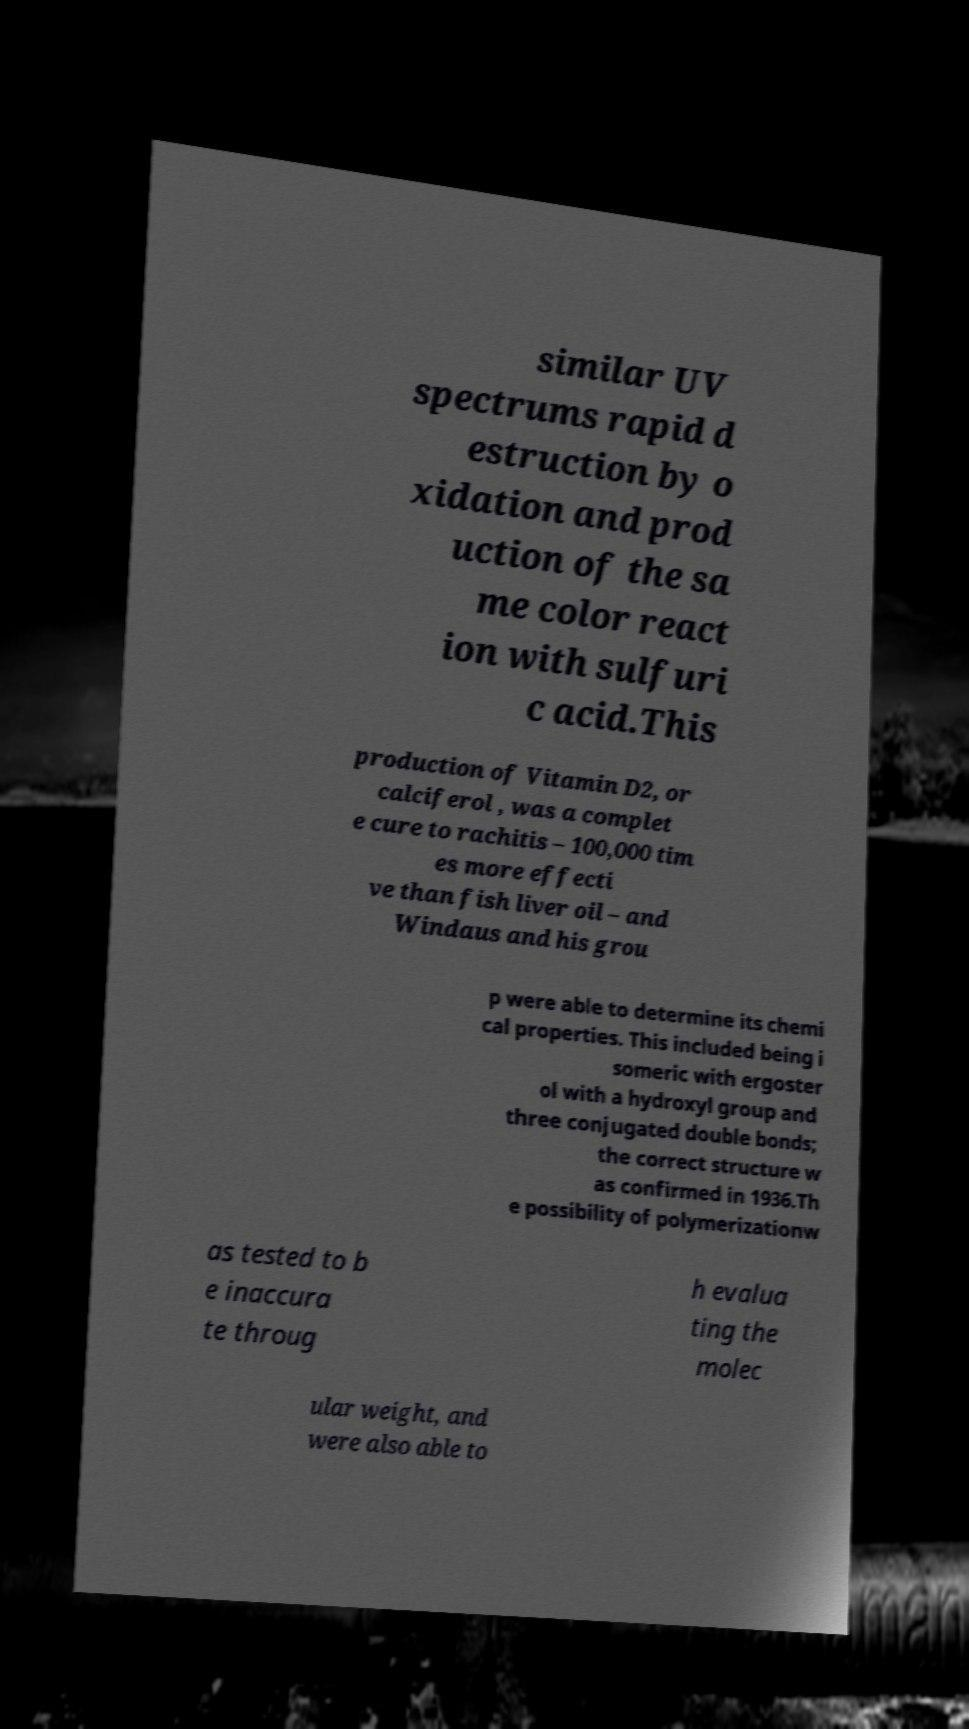Can you accurately transcribe the text from the provided image for me? similar UV spectrums rapid d estruction by o xidation and prod uction of the sa me color react ion with sulfuri c acid.This production of Vitamin D2, or calciferol , was a complet e cure to rachitis – 100,000 tim es more effecti ve than fish liver oil – and Windaus and his grou p were able to determine its chemi cal properties. This included being i someric with ergoster ol with a hydroxyl group and three conjugated double bonds; the correct structure w as confirmed in 1936.Th e possibility of polymerizationw as tested to b e inaccura te throug h evalua ting the molec ular weight, and were also able to 